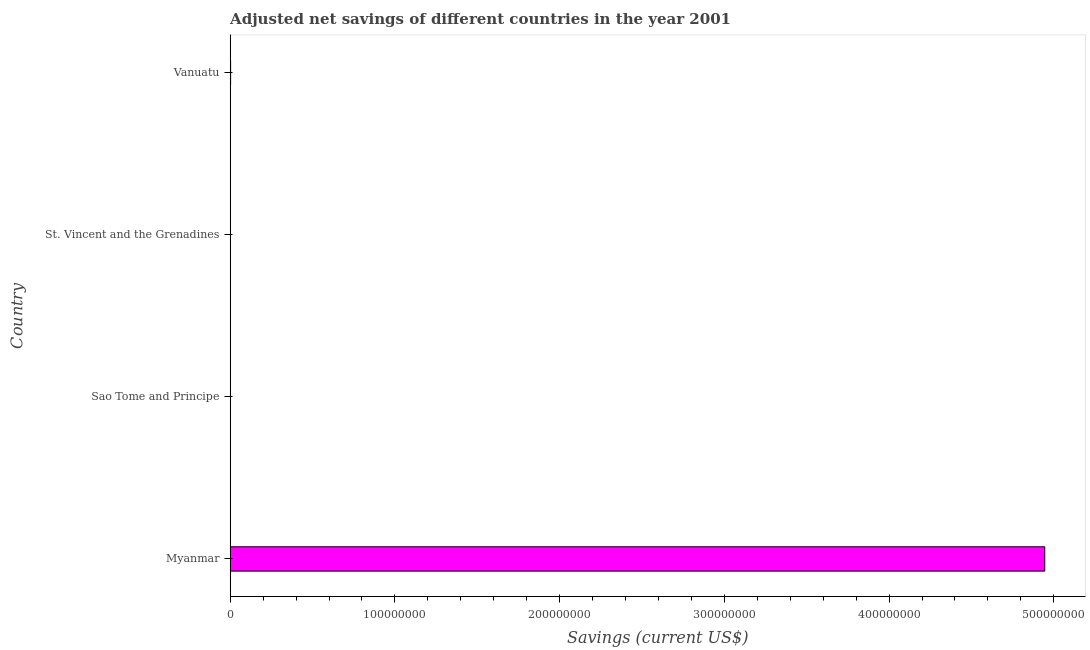Does the graph contain any zero values?
Offer a terse response. No. What is the title of the graph?
Your response must be concise. Adjusted net savings of different countries in the year 2001. What is the label or title of the X-axis?
Provide a short and direct response. Savings (current US$). What is the adjusted net savings in Vanuatu?
Provide a short and direct response. 2.52e+05. Across all countries, what is the maximum adjusted net savings?
Provide a short and direct response. 4.95e+08. Across all countries, what is the minimum adjusted net savings?
Your response must be concise. 5130.39. In which country was the adjusted net savings maximum?
Make the answer very short. Myanmar. In which country was the adjusted net savings minimum?
Give a very brief answer. Sao Tome and Principe. What is the sum of the adjusted net savings?
Offer a terse response. 4.95e+08. What is the difference between the adjusted net savings in Sao Tome and Principe and Vanuatu?
Give a very brief answer. -2.47e+05. What is the average adjusted net savings per country?
Your response must be concise. 1.24e+08. What is the median adjusted net savings?
Your answer should be compact. 1.91e+05. In how many countries, is the adjusted net savings greater than 260000000 US$?
Your answer should be very brief. 1. What is the ratio of the adjusted net savings in St. Vincent and the Grenadines to that in Vanuatu?
Make the answer very short. 0.52. Is the difference between the adjusted net savings in Myanmar and Vanuatu greater than the difference between any two countries?
Provide a short and direct response. No. What is the difference between the highest and the second highest adjusted net savings?
Keep it short and to the point. 4.94e+08. Is the sum of the adjusted net savings in St. Vincent and the Grenadines and Vanuatu greater than the maximum adjusted net savings across all countries?
Provide a short and direct response. No. What is the difference between the highest and the lowest adjusted net savings?
Provide a short and direct response. 4.95e+08. Are all the bars in the graph horizontal?
Keep it short and to the point. Yes. What is the difference between two consecutive major ticks on the X-axis?
Make the answer very short. 1.00e+08. What is the Savings (current US$) of Myanmar?
Offer a terse response. 4.95e+08. What is the Savings (current US$) in Sao Tome and Principe?
Your answer should be compact. 5130.39. What is the Savings (current US$) in St. Vincent and the Grenadines?
Your answer should be very brief. 1.30e+05. What is the Savings (current US$) of Vanuatu?
Ensure brevity in your answer.  2.52e+05. What is the difference between the Savings (current US$) in Myanmar and Sao Tome and Principe?
Offer a very short reply. 4.95e+08. What is the difference between the Savings (current US$) in Myanmar and St. Vincent and the Grenadines?
Your answer should be compact. 4.94e+08. What is the difference between the Savings (current US$) in Myanmar and Vanuatu?
Provide a succinct answer. 4.94e+08. What is the difference between the Savings (current US$) in Sao Tome and Principe and St. Vincent and the Grenadines?
Your answer should be very brief. -1.25e+05. What is the difference between the Savings (current US$) in Sao Tome and Principe and Vanuatu?
Ensure brevity in your answer.  -2.47e+05. What is the difference between the Savings (current US$) in St. Vincent and the Grenadines and Vanuatu?
Your answer should be compact. -1.22e+05. What is the ratio of the Savings (current US$) in Myanmar to that in Sao Tome and Principe?
Offer a very short reply. 9.64e+04. What is the ratio of the Savings (current US$) in Myanmar to that in St. Vincent and the Grenadines?
Provide a succinct answer. 3790.35. What is the ratio of the Savings (current US$) in Myanmar to that in Vanuatu?
Your answer should be compact. 1958.6. What is the ratio of the Savings (current US$) in Sao Tome and Principe to that in St. Vincent and the Grenadines?
Offer a terse response. 0.04. What is the ratio of the Savings (current US$) in St. Vincent and the Grenadines to that in Vanuatu?
Your answer should be compact. 0.52. 